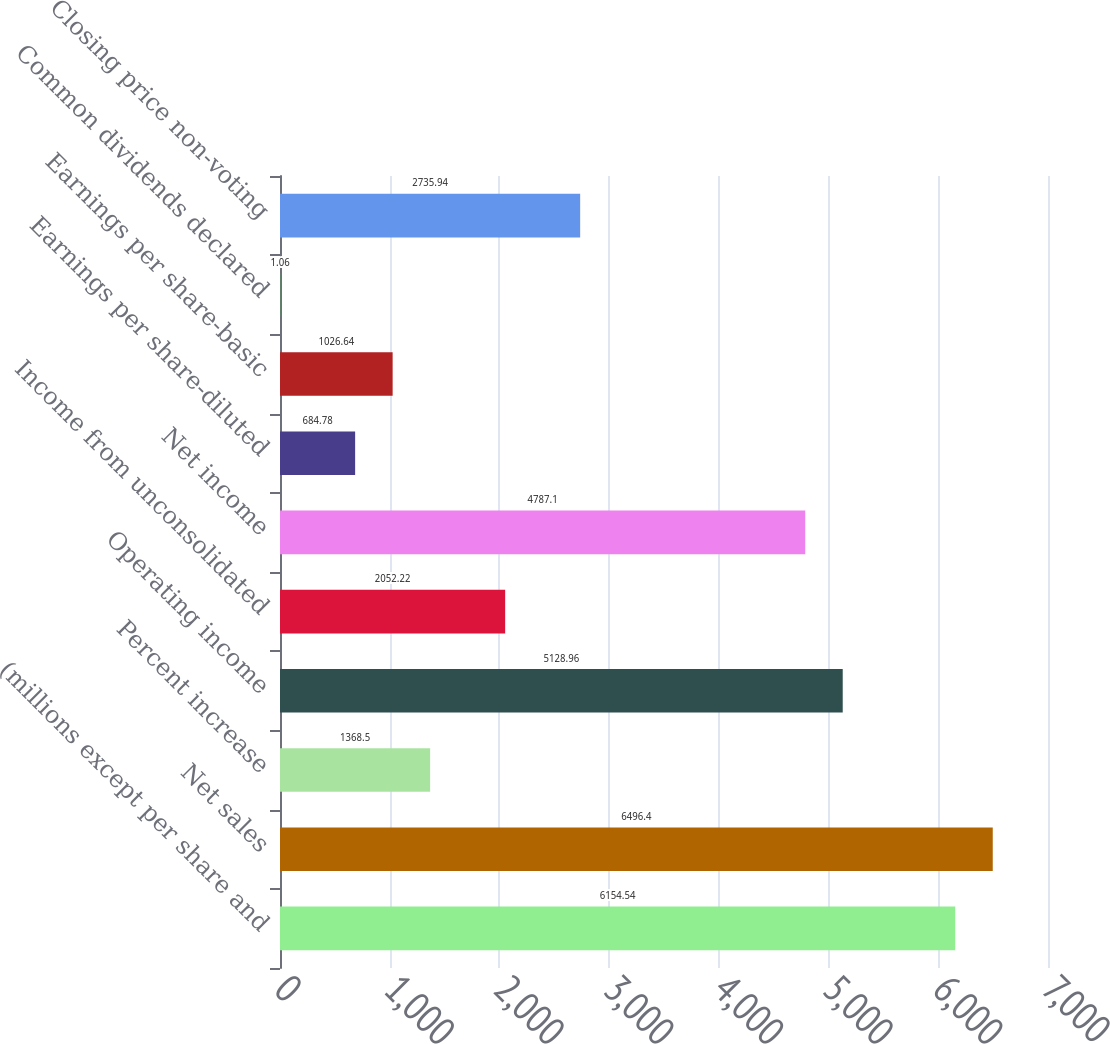Convert chart to OTSL. <chart><loc_0><loc_0><loc_500><loc_500><bar_chart><fcel>(millions except per share and<fcel>Net sales<fcel>Percent increase<fcel>Operating income<fcel>Income from unconsolidated<fcel>Net income<fcel>Earnings per share-diluted<fcel>Earnings per share-basic<fcel>Common dividends declared<fcel>Closing price non-voting<nl><fcel>6154.54<fcel>6496.4<fcel>1368.5<fcel>5128.96<fcel>2052.22<fcel>4787.1<fcel>684.78<fcel>1026.64<fcel>1.06<fcel>2735.94<nl></chart> 